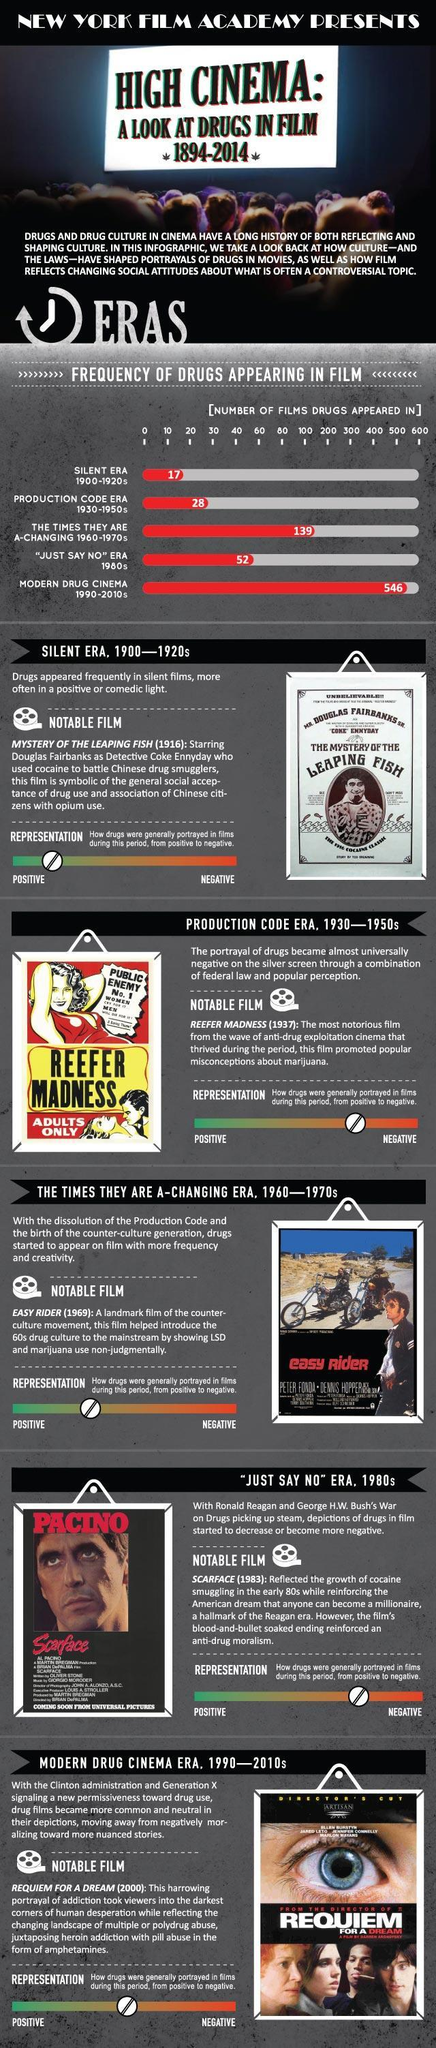During the 1980s did the appearance of drugs in movies increase or decrease?
Answer the question with a short phrase. decrease Which was the notable movie of the 60s era? Easy Rider Which actor played the lead role in a notable movie of the 'Just say No' era? Pacino Who was the lead character in the notable movie of the silent era? Douglas Fairbanks During which time period was the second highest number of drug appearances in films ? 1960-1970s Who were the lead characters in the notable movie of the 60s era? Peter Fonda, Dennis Hopper Which era of movies showed drug use in a negative perspective? production code era What was the name of the character in the notable movie depicting usage of drugs in the silent era? Detective Coke Ennyday During which time period the use of drugs was depicted in a more neutral way? 1990-2010s Which was a notable movie of the 'Just say No' era? Scarface 